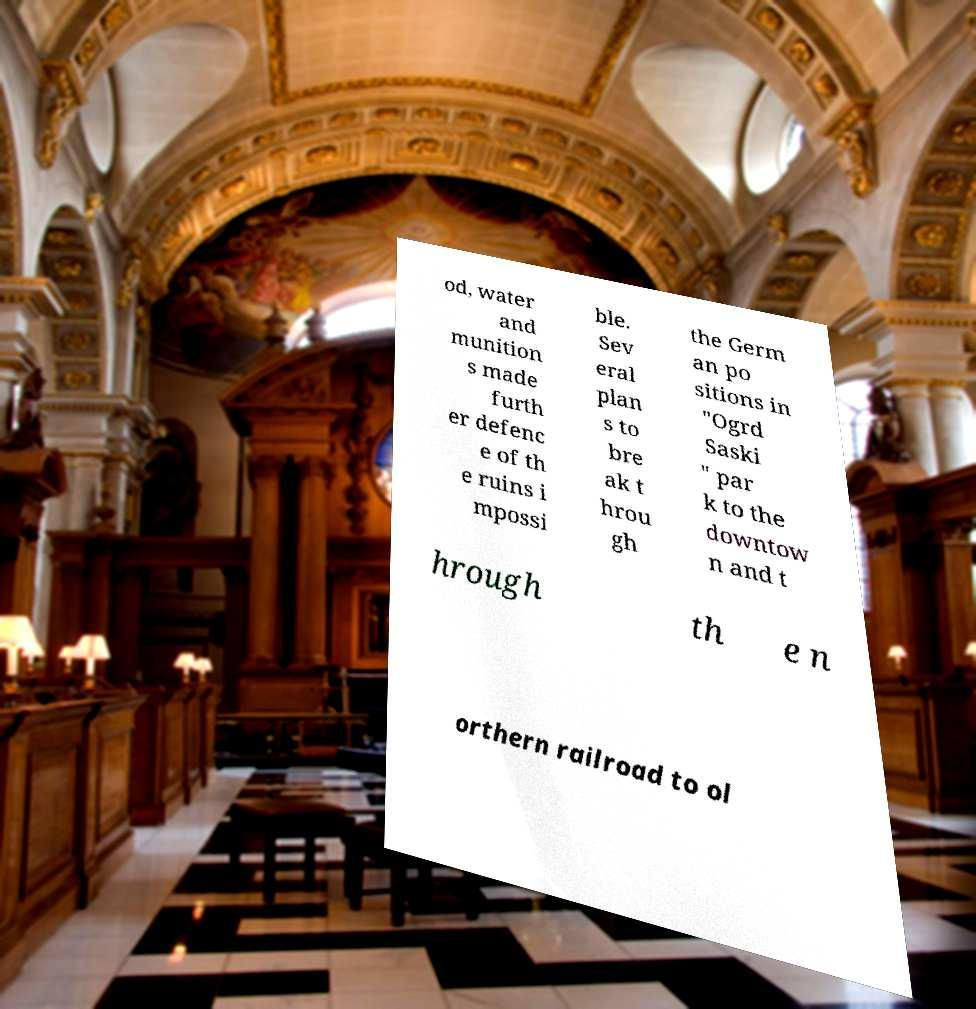Could you extract and type out the text from this image? od, water and munition s made furth er defenc e of th e ruins i mpossi ble. Sev eral plan s to bre ak t hrou gh the Germ an po sitions in "Ogrd Saski " par k to the downtow n and t hrough th e n orthern railroad to ol 